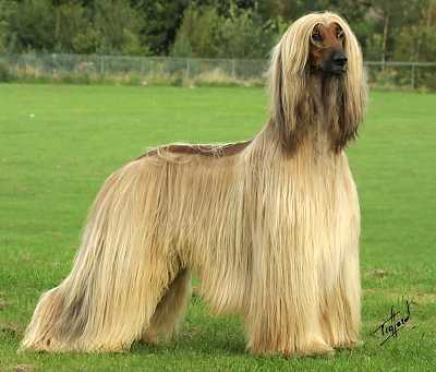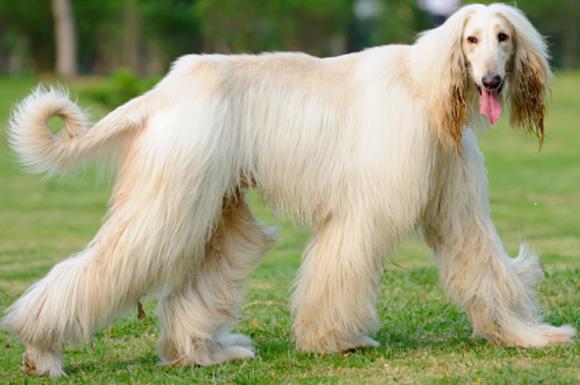The first image is the image on the left, the second image is the image on the right. Given the left and right images, does the statement "Both dogs are facing the same direction." hold true? Answer yes or no. Yes. The first image is the image on the left, the second image is the image on the right. Considering the images on both sides, is "There are no less than three dogs" valid? Answer yes or no. No. 